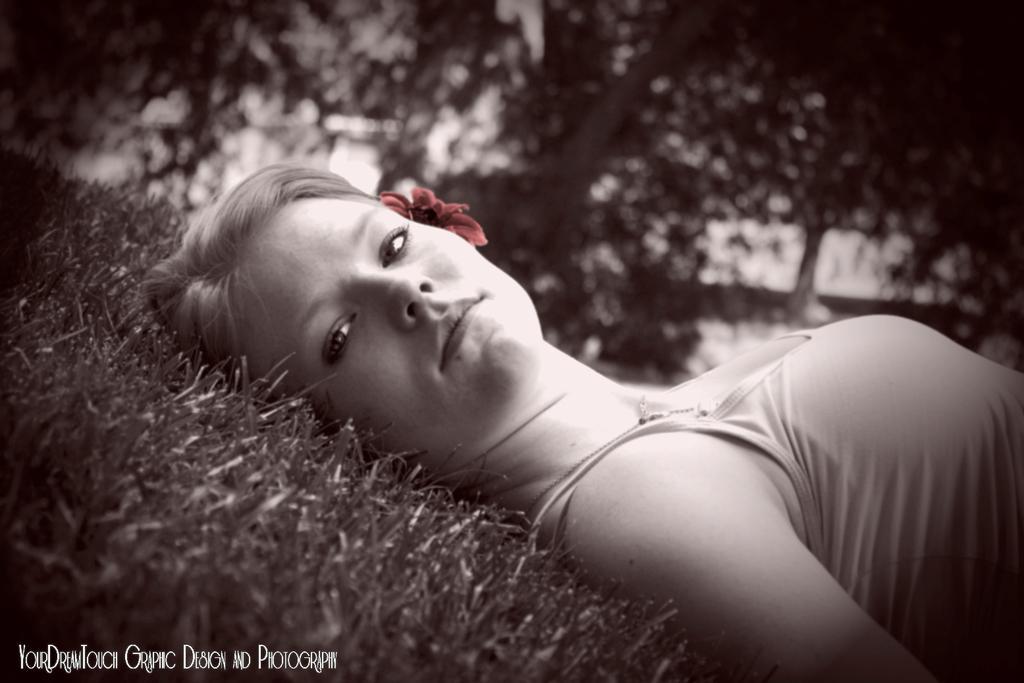Describe this image in one or two sentences. The image is in black and white, we can see there is a woman lying on the ground, at the back there are many trees, grass. 